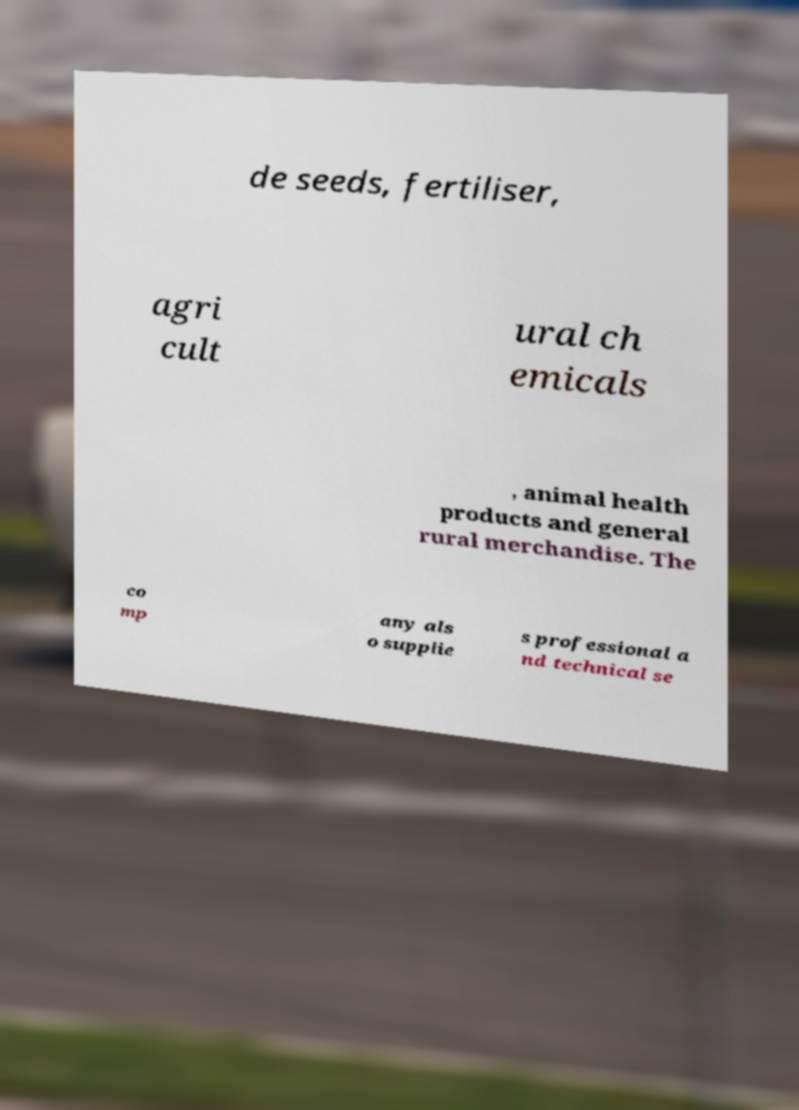Can you read and provide the text displayed in the image?This photo seems to have some interesting text. Can you extract and type it out for me? de seeds, fertiliser, agri cult ural ch emicals , animal health products and general rural merchandise. The co mp any als o supplie s professional a nd technical se 